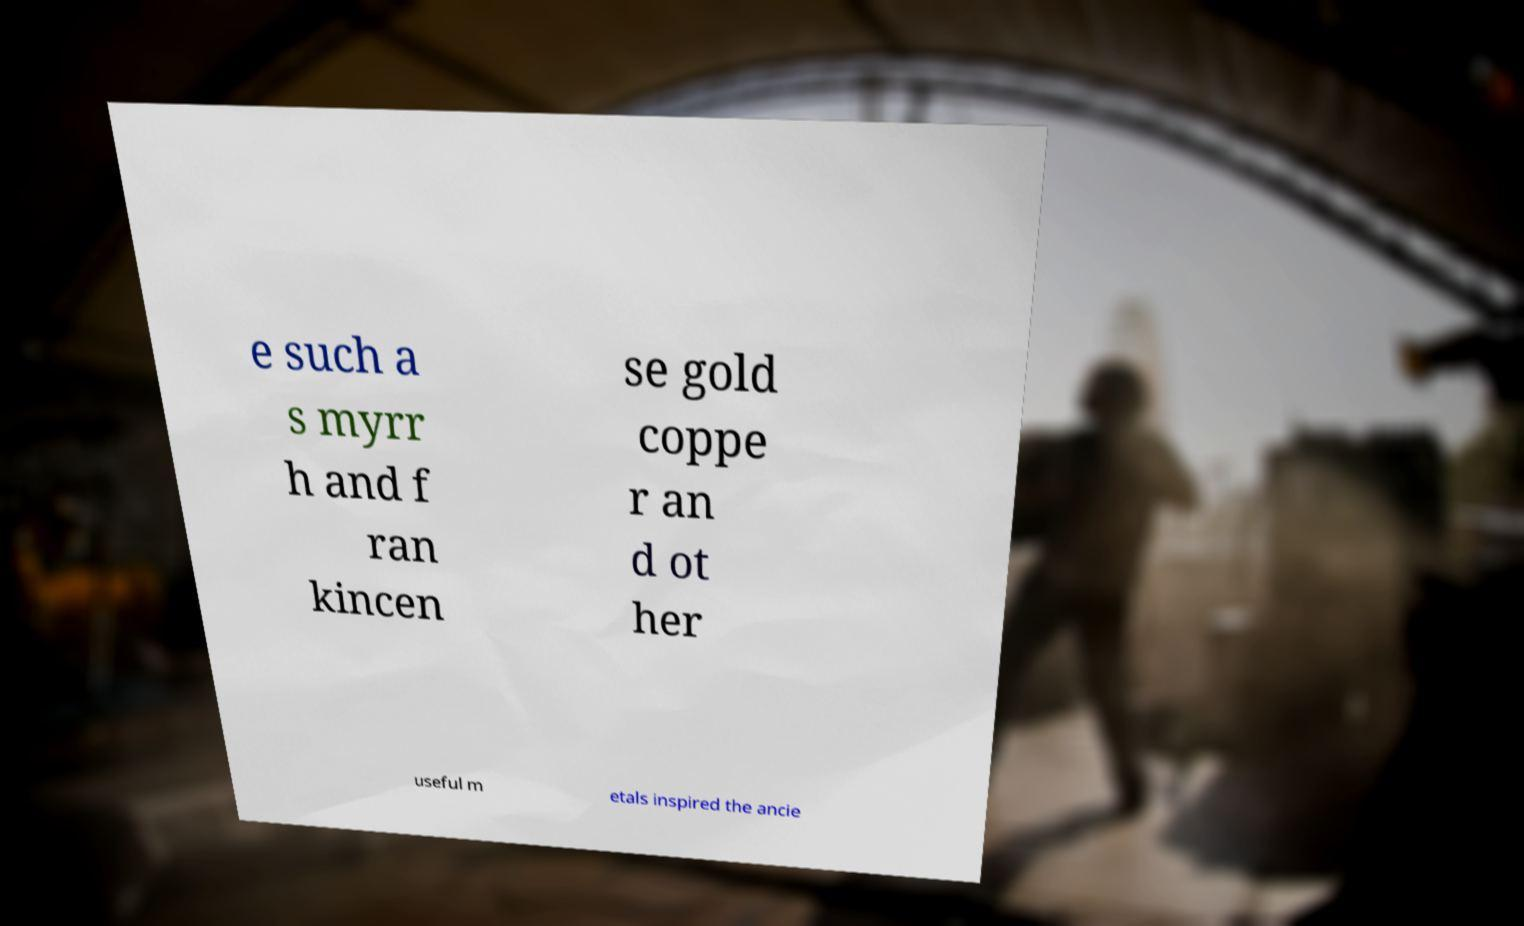Can you read and provide the text displayed in the image?This photo seems to have some interesting text. Can you extract and type it out for me? e such a s myrr h and f ran kincen se gold coppe r an d ot her useful m etals inspired the ancie 